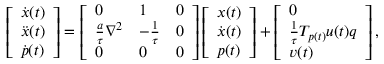<formula> <loc_0><loc_0><loc_500><loc_500>\left [ \begin{array} { l } { \dot { x } ( t ) } \\ { \ddot { x } ( t ) } \\ { \dot { p } ( t ) } \end{array} \right ] = \left [ \begin{array} { l l l } { 0 } & { 1 } & { 0 } \\ { \frac { a } { \tau } \nabla ^ { 2 } } & { - \frac { 1 } { \tau } } & { 0 } \\ { 0 } & { 0 } & { 0 } \end{array} \right ] \left [ \begin{array} { l } { x ( t ) } \\ { \dot { x } ( t ) } \\ { p ( t ) } \end{array} \right ] + \left [ \begin{array} { l } { 0 } \\ { \frac { 1 } { \tau } T _ { p ( t ) } u ( t ) q } \\ { v ( t ) } \end{array} \right ] ,</formula> 